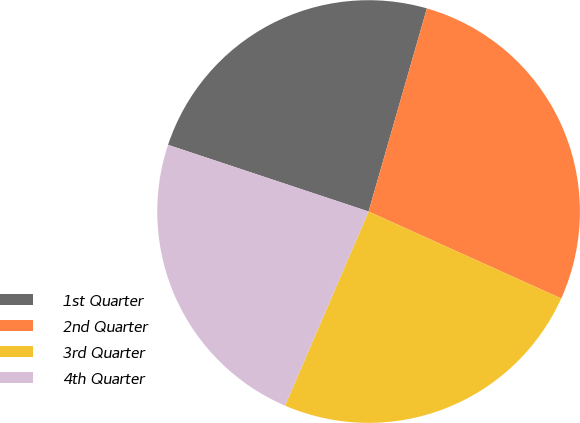Convert chart to OTSL. <chart><loc_0><loc_0><loc_500><loc_500><pie_chart><fcel>1st Quarter<fcel>2nd Quarter<fcel>3rd Quarter<fcel>4th Quarter<nl><fcel>24.34%<fcel>27.3%<fcel>24.72%<fcel>23.64%<nl></chart> 